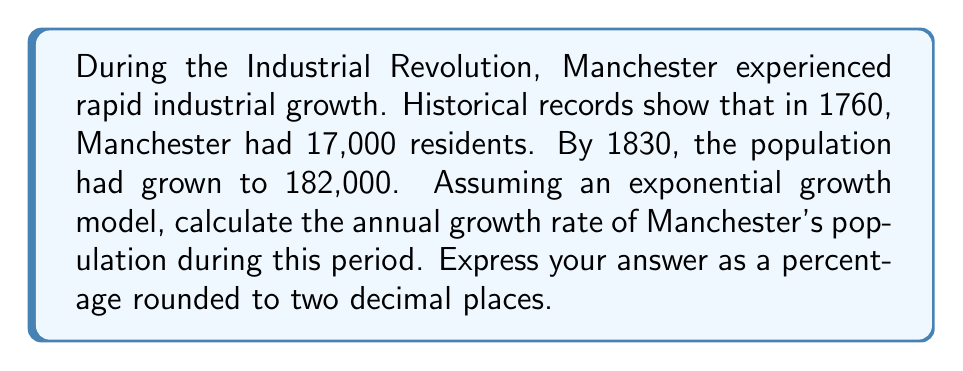What is the answer to this math problem? To solve this problem, we'll use the exponential growth model:

$$P(t) = P_0 \cdot e^{rt}$$

Where:
$P(t)$ is the population at time $t$
$P_0$ is the initial population
$r$ is the annual growth rate
$t$ is the time in years

Given:
$P_0 = 17,000$ (population in 1760)
$P(t) = 182,000$ (population in 1830)
$t = 70$ years (from 1760 to 1830)

Let's substitute these values into the equation:

$$182,000 = 17,000 \cdot e^{70r}$$

Now, let's solve for $r$:

1) Divide both sides by 17,000:
   $$\frac{182,000}{17,000} = e^{70r}$$

2) Take the natural logarithm of both sides:
   $$\ln(\frac{182,000}{17,000}) = \ln(e^{70r})$$

3) Simplify the right side using the property of logarithms:
   $$\ln(\frac{182,000}{17,000}) = 70r$$

4) Solve for $r$:
   $$r = \frac{\ln(\frac{182,000}{17,000})}{70}$$

5) Calculate the value:
   $$r = \frac{\ln(10.7058824)}{70} \approx 0.0338$$

6) Convert to a percentage:
   $$0.0338 \times 100\% = 3.38\%$$

Therefore, the annual growth rate of Manchester's population during this period of the Industrial Revolution was approximately 3.38%.
Answer: 3.38% 